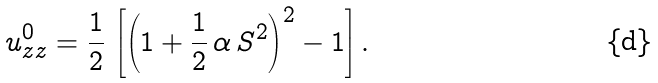Convert formula to latex. <formula><loc_0><loc_0><loc_500><loc_500>u _ { z z } ^ { 0 } = \frac { 1 } { 2 } \, \left [ \left ( 1 + \frac { 1 } { 2 } \, \alpha \, S ^ { 2 } \right ) ^ { 2 } - 1 \right ] .</formula> 